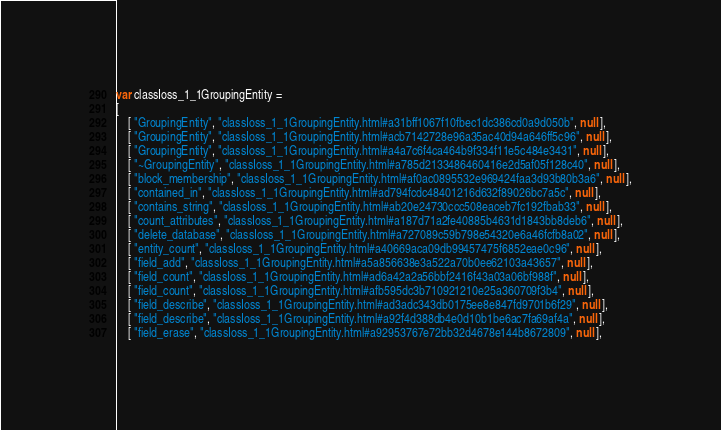Convert code to text. <code><loc_0><loc_0><loc_500><loc_500><_JavaScript_>var classIoss_1_1GroupingEntity =
[
    [ "GroupingEntity", "classIoss_1_1GroupingEntity.html#a31bff1067f10fbec1dc386cd0a9d050b", null ],
    [ "GroupingEntity", "classIoss_1_1GroupingEntity.html#acb7142728e96a35ac40d94a646ff5c96", null ],
    [ "GroupingEntity", "classIoss_1_1GroupingEntity.html#a4a7c6f4ca464b9f334f11e5c484e3431", null ],
    [ "~GroupingEntity", "classIoss_1_1GroupingEntity.html#a785d2133486460416e2d5af05f128c40", null ],
    [ "block_membership", "classIoss_1_1GroupingEntity.html#af0ac0895532e969424faa3d93b80b3a6", null ],
    [ "contained_in", "classIoss_1_1GroupingEntity.html#ad794fcdc48401216d632f89026bc7a5c", null ],
    [ "contains_string", "classIoss_1_1GroupingEntity.html#ab20e24730ccc508eaceb7fc192fbab33", null ],
    [ "count_attributes", "classIoss_1_1GroupingEntity.html#a187d71a2fe40885b4631d1843bb8deb6", null ],
    [ "delete_database", "classIoss_1_1GroupingEntity.html#a727089c59b798e54320e6a46fcfb8a02", null ],
    [ "entity_count", "classIoss_1_1GroupingEntity.html#a40669aca09db99457475f6852eae0c96", null ],
    [ "field_add", "classIoss_1_1GroupingEntity.html#a5a856638e3a522a70b0ee62103a43657", null ],
    [ "field_count", "classIoss_1_1GroupingEntity.html#ad6a42a2a56bbf2416f43a03a06bf988f", null ],
    [ "field_count", "classIoss_1_1GroupingEntity.html#afb595dc3b710921210e25a360709f3b4", null ],
    [ "field_describe", "classIoss_1_1GroupingEntity.html#ad3adc343db0175ee8e847fd9701b6f29", null ],
    [ "field_describe", "classIoss_1_1GroupingEntity.html#a92f4d388db4e0d10b1be6ac7fa69af4a", null ],
    [ "field_erase", "classIoss_1_1GroupingEntity.html#a92953767e72bb32d4678e144b8672809", null ],</code> 